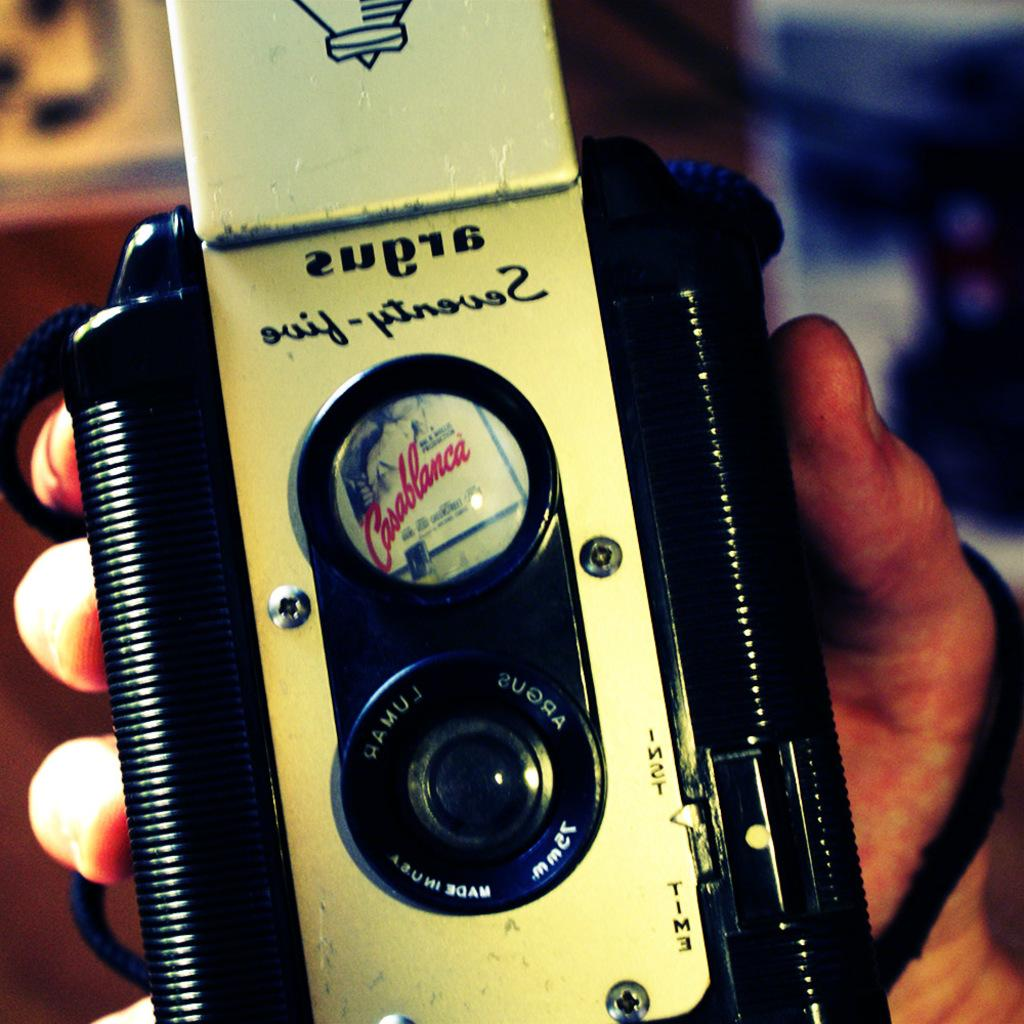What is the main subject of the image? There is a person in the image. What is the person holding in the image? The person is holding an object. Can you describe the background of the image? The background of the image is blurry. What type of committee is meeting in the image? There is no committee meeting present in the image. What type of prose is the person reading in the image? There is no reading material visible in the image. What type of tool is the person using in the image? We cannot determine the type of tool the person is using, as the object they are holding is not specified in the provided facts. 